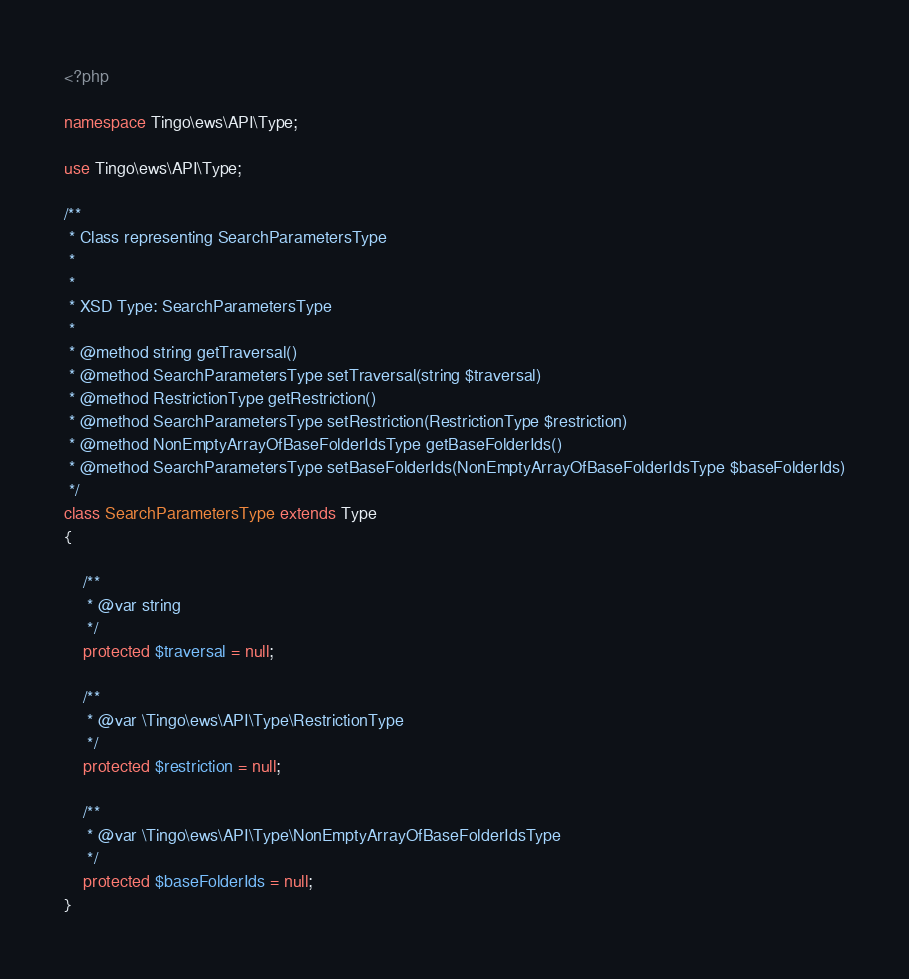Convert code to text. <code><loc_0><loc_0><loc_500><loc_500><_PHP_><?php

namespace Tingo\ews\API\Type;

use Tingo\ews\API\Type;

/**
 * Class representing SearchParametersType
 *
 *
 * XSD Type: SearchParametersType
 *
 * @method string getTraversal()
 * @method SearchParametersType setTraversal(string $traversal)
 * @method RestrictionType getRestriction()
 * @method SearchParametersType setRestriction(RestrictionType $restriction)
 * @method NonEmptyArrayOfBaseFolderIdsType getBaseFolderIds()
 * @method SearchParametersType setBaseFolderIds(NonEmptyArrayOfBaseFolderIdsType $baseFolderIds)
 */
class SearchParametersType extends Type
{

    /**
     * @var string
     */
    protected $traversal = null;

    /**
     * @var \Tingo\ews\API\Type\RestrictionType
     */
    protected $restriction = null;

    /**
     * @var \Tingo\ews\API\Type\NonEmptyArrayOfBaseFolderIdsType
     */
    protected $baseFolderIds = null;
}
</code> 